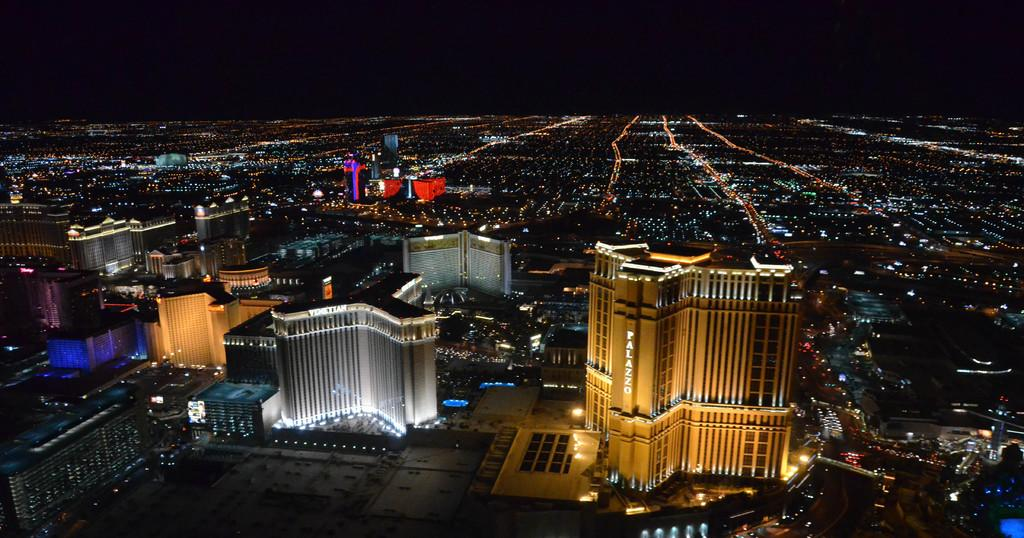What type of view is shown in the image? The image is an outside view. What time of day is suggested by the image? The image was clicked in the dark, suggesting nighttime. What structures are visible in the image? There are many buildings visible in the image. What is the source of illumination in the image? There are lights on the land in the image. What type of wax is being used to create a twist in the image? There is no wax or twist present in the image. Is there a notebook visible in the image? No, there is no notebook visible in the image. 